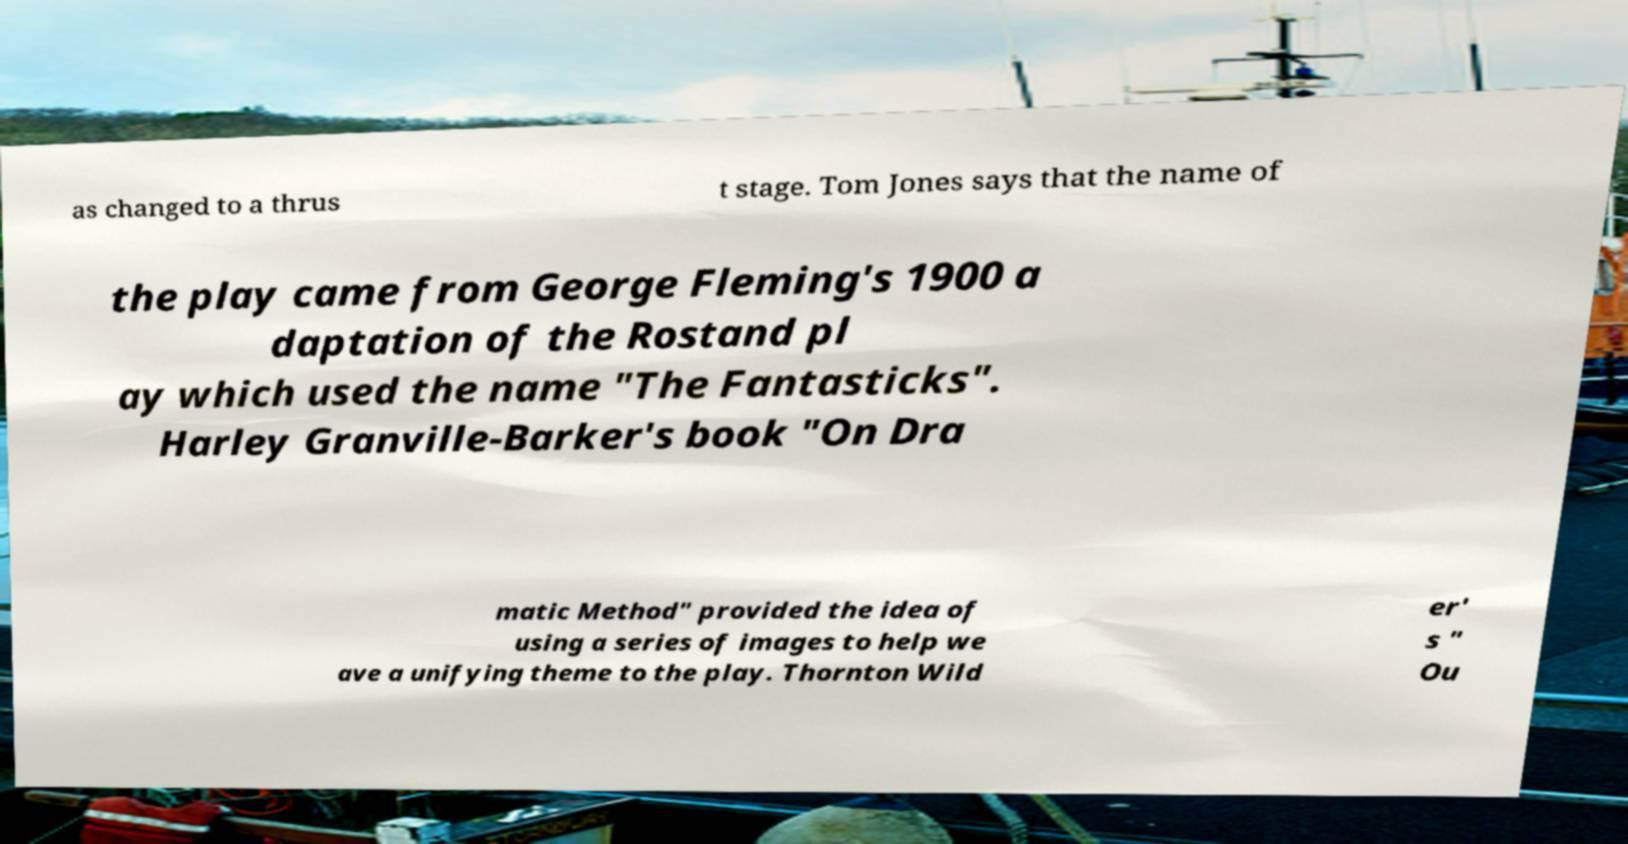For documentation purposes, I need the text within this image transcribed. Could you provide that? as changed to a thrus t stage. Tom Jones says that the name of the play came from George Fleming's 1900 a daptation of the Rostand pl ay which used the name "The Fantasticks". Harley Granville-Barker's book "On Dra matic Method" provided the idea of using a series of images to help we ave a unifying theme to the play. Thornton Wild er' s " Ou 